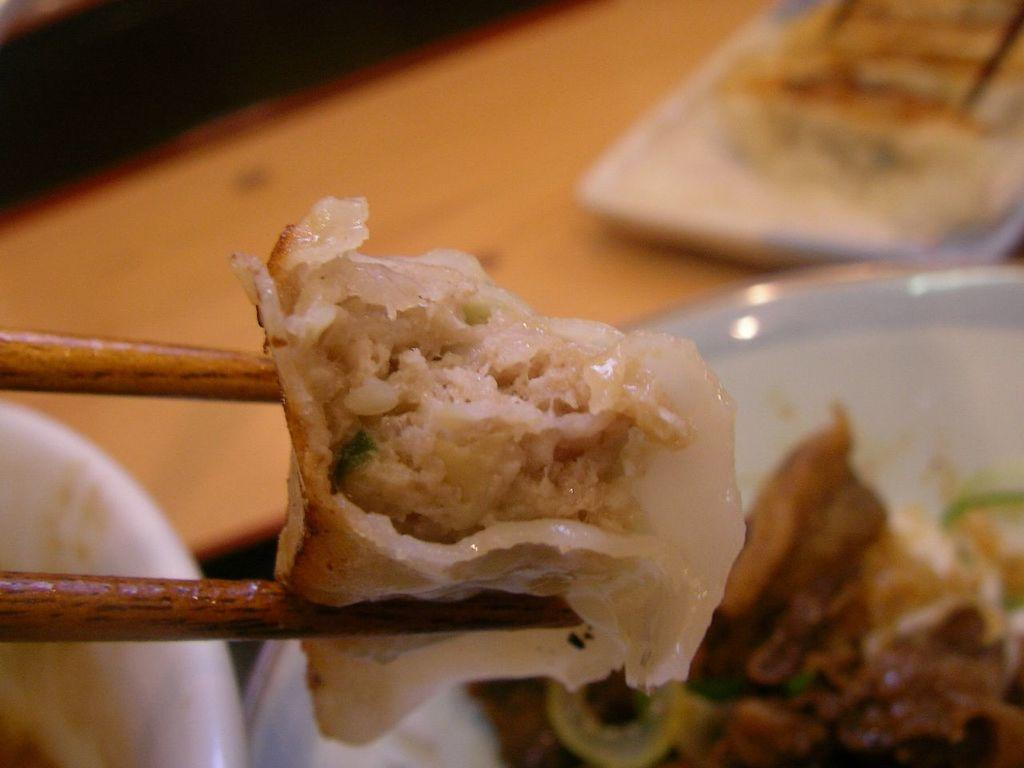What is the person in the image doing? The person is holding food with chopsticks. What can be seen on the table in the image? There are plates and a bowl on the table. Where is the kitten sleeping in the image? There is no kitten present in the image. What type of vegetable is being served on the plates in the image? The provided facts do not mention any specific type of food being served, so we cannot determine if there is cabbage or any other vegetable on the plates. 